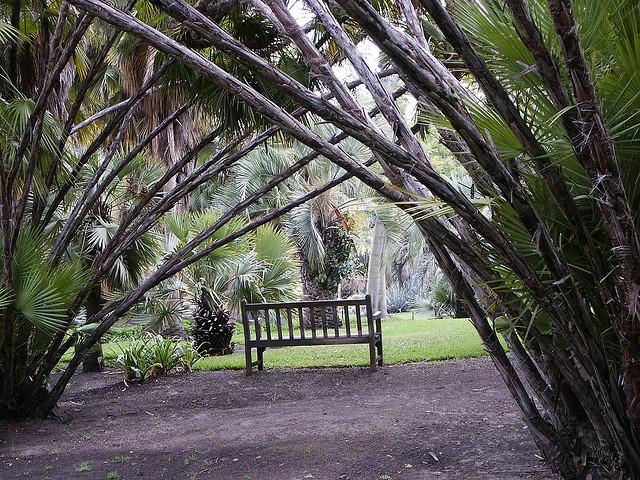Is this a tropical climate?
Concise answer only. Yes. How many beaches are near the grass?
Be succinct. 1. Are there any people?
Answer briefly. No. What separates the sidewalk from the wildlife?
Write a very short answer. Bench. 